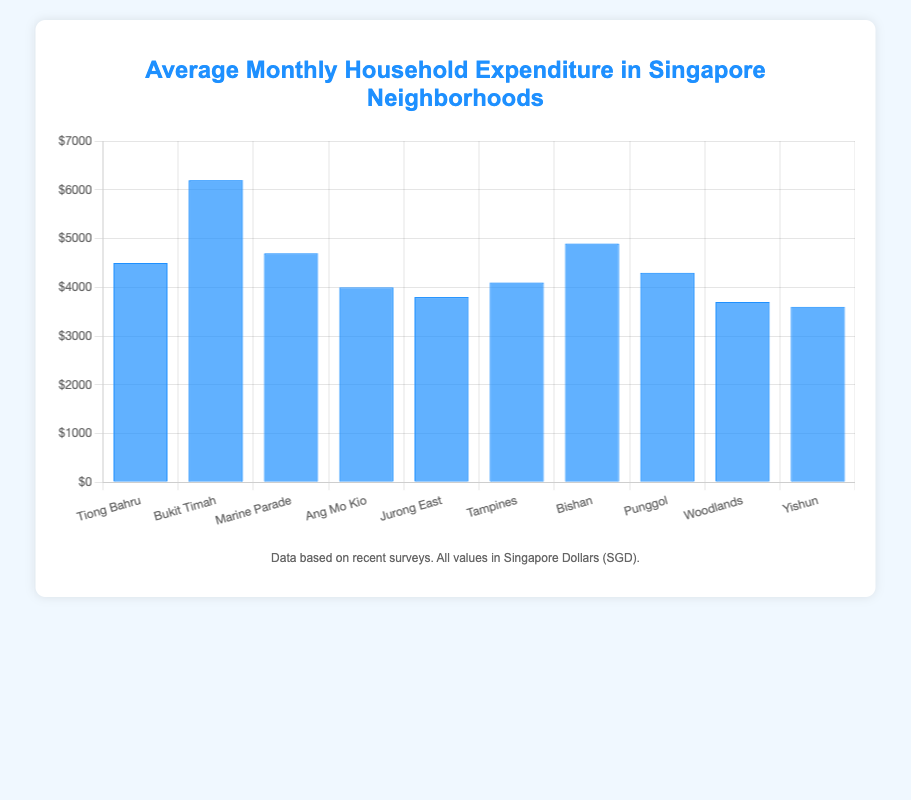Which neighborhood has the highest average monthly household expenditure? The figure shows that the neighborhood with the highest bar represents Bukit Timah.
Answer: Bukit Timah Which neighborhood has the lowest average monthly household expenditure? The figure shows that the neighborhood with the lowest bar represents Yishun.
Answer: Yishun How much greater is the average monthly household expenditure in Bukit Timah compared to Tiong Bahru? The average monthly expenditure in Bukit Timah is $6200, and in Tiong Bahru, it is $4500. The difference is $6200 - $4500 = $1700.
Answer: $1700 What is the combined average monthly household expenditure for Ang Mo Kio and Tampines? The average monthly expenditure for Ang Mo Kio is $4000 and for Tampines is $4100. Combined, it is $4000 + $4100 = $8100.
Answer: $8100 What is the difference in average monthly household expenditure between Marine Parade and Woodlands? Marine Parade has an expenditure of $4700 and Woodlands has $3700. The difference is $4700 - $3700 = $1000.
Answer: $1000 How does the expenditure in Punggol compare to Jurong East? Which is higher and by how much? Punggol's expenditure is $4300 and Jurong East's is $3800. Punggol is higher by $4300 - $3800 = $500.
Answer: Punggol, $500 What is the average expenditure of Jurong East, Tampines, and Bishan? Summing the expenditures of Jurong East ($3800), Tampines ($4100), and Bishan ($4900), we get $3800 + $4100 + $4900 = $12800. The average is $12800 / 3 = $4266.67.
Answer: $4266.67 What is the total average monthly household expenditure for all neighborhoods combined? Summing the expenditures of all neighborhoods: $4500 + $6200 + $4700 + $4000 + $3800 + $4100 + $4900 + $4300 + $3700 + $3600 = $43800.
Answer: $43800 How much higher is the expenditure in Bishan compared to Yishun? Bishan has an expenditure of $4900 and Yishun has $3600. The difference is $4900 - $3600 = $1300.
Answer: $1300 